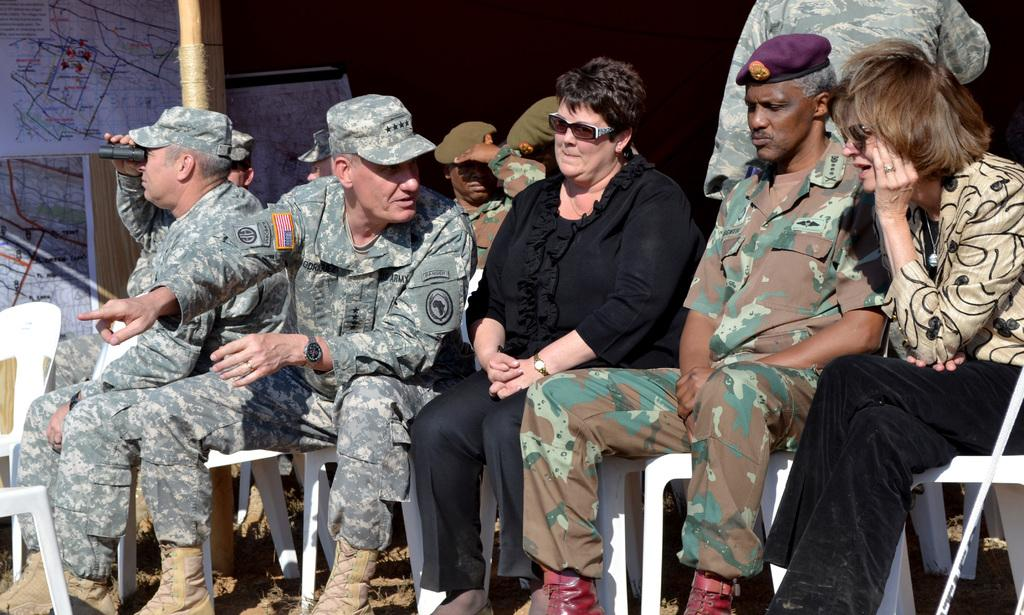How many ladies are sitting in the image? There are two ladies sitting in the image. What type of clothing are some people wearing in the image? There are people wearing uniforms in the image. What can be seen on the left side of the image? There are boards placed on the wall on the left side of the image. What type of stem can be seen growing from the ladies' heads in the image? There are no stems growing from the ladies' heads in the image. 